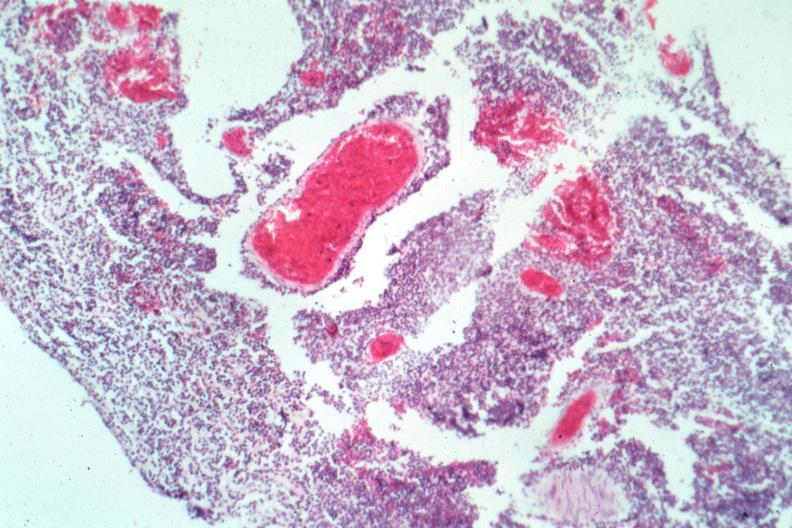what is present?
Answer the question using a single word or phrase. Brain 